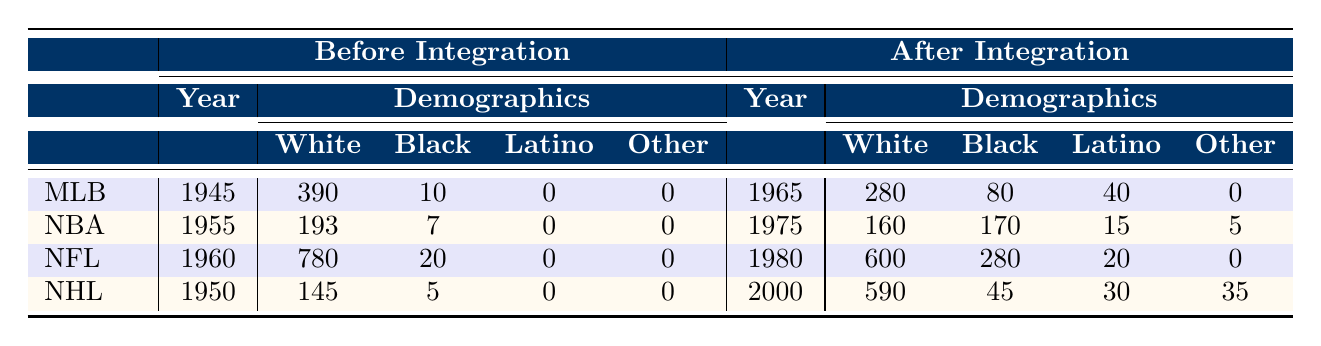What was the total number of Black players in Major League Baseball before integration? The table for Major League Baseball indicates that in 1945, there were 10 Black players.
Answer: 10 What percentage of players in the NFL were Black after integration in 1980? In 1980, there were 280 Black players out of a total of 900 players in the NFL. To find the percentage, we calculate (280/900) * 100 = 31.11%.
Answer: 31.11% Which league had the highest percentage of Black players after integration? Analyzing the after integration data, the NBA in 1975 had 170 Black players out of 350 total, which is about 48.57%. The NFL had about 31.11%, the MLB had 20%, and the NHL had about 6.43%. Thus, the NBA had the highest percentage.
Answer: NBA How many total players did Major League Baseball have before and after integration combined? Major League Baseball had 400 players before integration in 1945 and 400 players after integration in 1965. Therefore, the combined total is 400 + 400 = 800 players.
Answer: 800 In which league did the percentage of White players decrease the most from before to after integration? For the MLB, the percentage of White players decreased from 97.5% to 70%; for the NBA, it decreased from 96.5% to 45.7%; for the NFL, it decreased from 97.5% to 66.7%; for the NHL, it decreased from 96.7% to 84.3%. The NBA experienced the largest decrease in percentage of White players when we calculate the change: 96.5% - 45.7% = 50.8%.
Answer: NBA What was the change in the number of Latino players in Major League Baseball from before to after integration? In 1945, Major League Baseball had 0 Latino players. By 1965, they had 40 Latino players. The change is calculated as 40 - 0 = 40.
Answer: 40 Was the total number of players in the NHL greater after integration compared to before integration? In 1950, the NHL had 150 players. By 2000, the NHL had 700 players. Since 700 > 150, the total number of players in the NHL was indeed greater after integration.
Answer: Yes How many more Black players were in the NFL after integration compared to before? The NFL had 20 Black players before integration in 1960 and 280 Black players after integration in 1980. The difference is calculated as 280 - 20 = 260.
Answer: 260 What was the total number of White players in the NBA before and after integration? In 1955, the NBA had 193 White players before integration and 160 White players after integration in 1975. The total is 193 + 160 = 353 White players.
Answer: 353 Which sport saw the least increase in the number of Latino players after integration? Analyzing the increases, MLB had an increase of 40 Latino players; the NBA had an increase of 15; the NFL had an increase of 20, and the NHL had an increase of 30. The NBA had the least increase.
Answer: NBA What is the total change in the number of players across all leagues from before integration to after integration? Summing the changes: MLB (0), NBA (150), NFL (100), and NHL (550). The total change is 0 + 150 + 100 + 550 = 800.
Answer: 800 